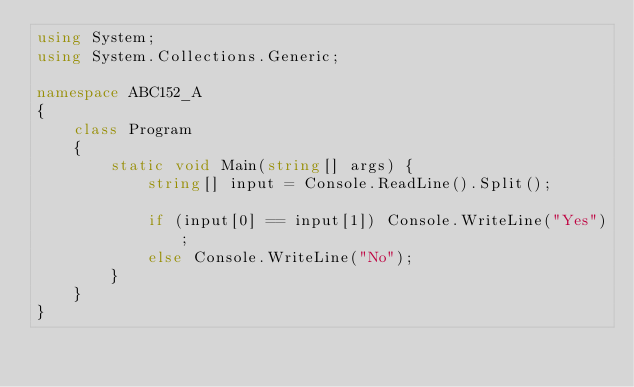<code> <loc_0><loc_0><loc_500><loc_500><_C#_>using System;
using System.Collections.Generic;

namespace ABC152_A
{
    class Program
    {
        static void Main(string[] args) {
            string[] input = Console.ReadLine().Split();

            if (input[0] == input[1]) Console.WriteLine("Yes");
            else Console.WriteLine("No");
        }
    }
}</code> 